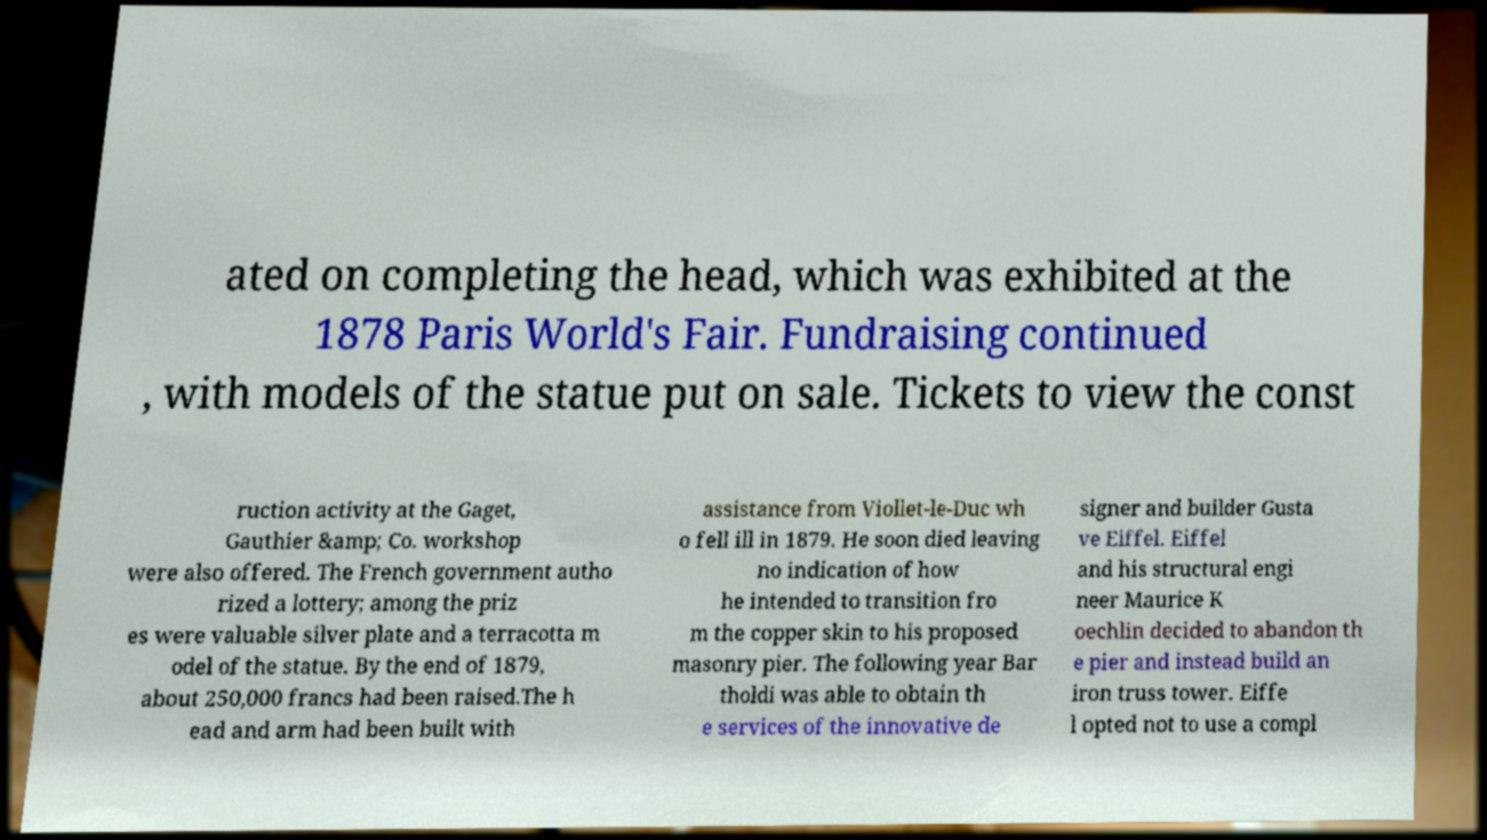There's text embedded in this image that I need extracted. Can you transcribe it verbatim? ated on completing the head, which was exhibited at the 1878 Paris World's Fair. Fundraising continued , with models of the statue put on sale. Tickets to view the const ruction activity at the Gaget, Gauthier &amp; Co. workshop were also offered. The French government autho rized a lottery; among the priz es were valuable silver plate and a terracotta m odel of the statue. By the end of 1879, about 250,000 francs had been raised.The h ead and arm had been built with assistance from Viollet-le-Duc wh o fell ill in 1879. He soon died leaving no indication of how he intended to transition fro m the copper skin to his proposed masonry pier. The following year Bar tholdi was able to obtain th e services of the innovative de signer and builder Gusta ve Eiffel. Eiffel and his structural engi neer Maurice K oechlin decided to abandon th e pier and instead build an iron truss tower. Eiffe l opted not to use a compl 